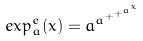Convert formula to latex. <formula><loc_0><loc_0><loc_500><loc_500>e x p _ { a } ^ { e } ( x ) = a ^ { a ^ { + ^ { + ^ { a ^ { x } } } } }</formula> 